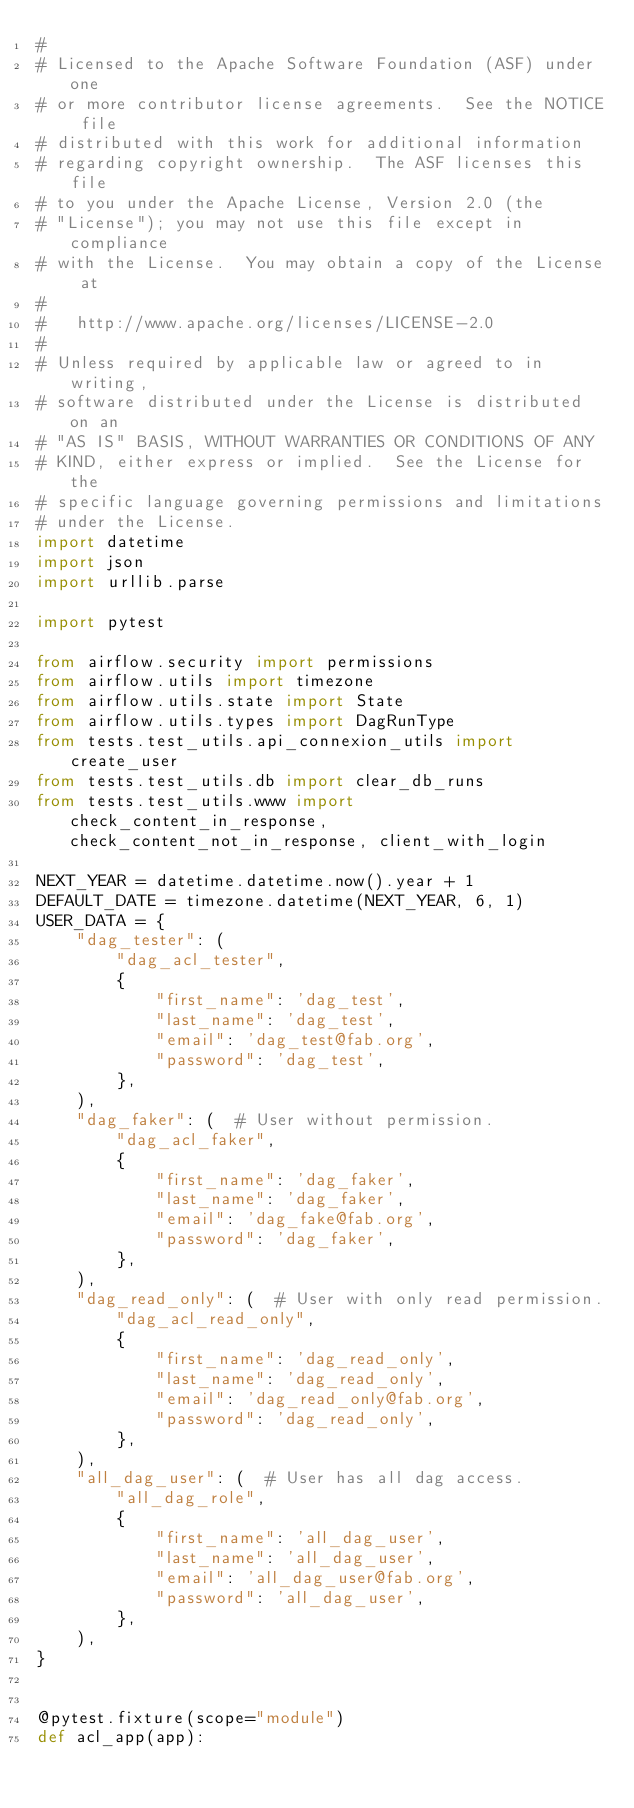Convert code to text. <code><loc_0><loc_0><loc_500><loc_500><_Python_>#
# Licensed to the Apache Software Foundation (ASF) under one
# or more contributor license agreements.  See the NOTICE file
# distributed with this work for additional information
# regarding copyright ownership.  The ASF licenses this file
# to you under the Apache License, Version 2.0 (the
# "License"); you may not use this file except in compliance
# with the License.  You may obtain a copy of the License at
#
#   http://www.apache.org/licenses/LICENSE-2.0
#
# Unless required by applicable law or agreed to in writing,
# software distributed under the License is distributed on an
# "AS IS" BASIS, WITHOUT WARRANTIES OR CONDITIONS OF ANY
# KIND, either express or implied.  See the License for the
# specific language governing permissions and limitations
# under the License.
import datetime
import json
import urllib.parse

import pytest

from airflow.security import permissions
from airflow.utils import timezone
from airflow.utils.state import State
from airflow.utils.types import DagRunType
from tests.test_utils.api_connexion_utils import create_user
from tests.test_utils.db import clear_db_runs
from tests.test_utils.www import check_content_in_response, check_content_not_in_response, client_with_login

NEXT_YEAR = datetime.datetime.now().year + 1
DEFAULT_DATE = timezone.datetime(NEXT_YEAR, 6, 1)
USER_DATA = {
    "dag_tester": (
        "dag_acl_tester",
        {
            "first_name": 'dag_test',
            "last_name": 'dag_test',
            "email": 'dag_test@fab.org',
            "password": 'dag_test',
        },
    ),
    "dag_faker": (  # User without permission.
        "dag_acl_faker",
        {
            "first_name": 'dag_faker',
            "last_name": 'dag_faker',
            "email": 'dag_fake@fab.org',
            "password": 'dag_faker',
        },
    ),
    "dag_read_only": (  # User with only read permission.
        "dag_acl_read_only",
        {
            "first_name": 'dag_read_only',
            "last_name": 'dag_read_only',
            "email": 'dag_read_only@fab.org',
            "password": 'dag_read_only',
        },
    ),
    "all_dag_user": (  # User has all dag access.
        "all_dag_role",
        {
            "first_name": 'all_dag_user',
            "last_name": 'all_dag_user',
            "email": 'all_dag_user@fab.org',
            "password": 'all_dag_user',
        },
    ),
}


@pytest.fixture(scope="module")
def acl_app(app):</code> 